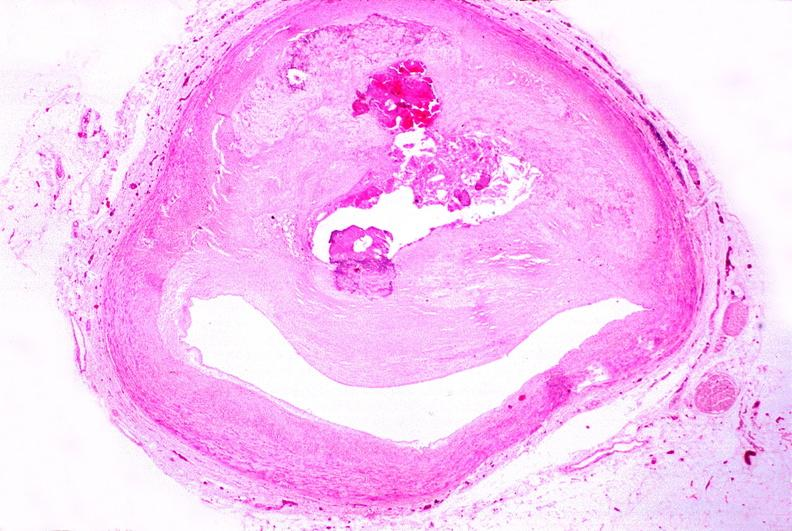s lymphangiomatosis present?
Answer the question using a single word or phrase. No 